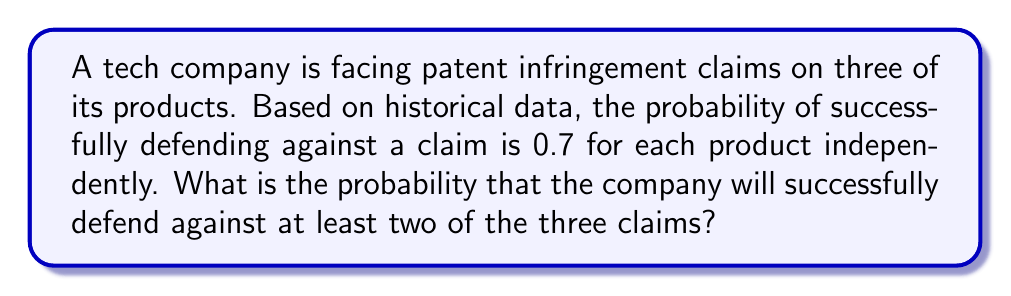Teach me how to tackle this problem. Let's approach this step-by-step:

1) First, we need to identify that this is a binomial probability problem.

2) We have three independent trials (three patent claims), each with a success probability of 0.7.

3) We want to find the probability of at least two successes out of three trials.

4) The probability of at least two successes is equal to the probability of exactly two successes plus the probability of three successes.

5) Let's calculate these probabilities:

   For exactly two successes:
   $$P(X=2) = \binom{3}{2} \cdot 0.7^2 \cdot 0.3^1 = 3 \cdot 0.49 \cdot 0.3 = 0.441$$

   For three successes:
   $$P(X=3) = \binom{3}{3} \cdot 0.7^3 \cdot 0.3^0 = 1 \cdot 0.343 \cdot 1 = 0.343$$

6) Now, we sum these probabilities:
   $$P(X \geq 2) = P(X=2) + P(X=3) = 0.441 + 0.343 = 0.784$$

Therefore, the probability of successfully defending against at least two of the three claims is 0.784 or 78.4%.
Answer: 0.784 